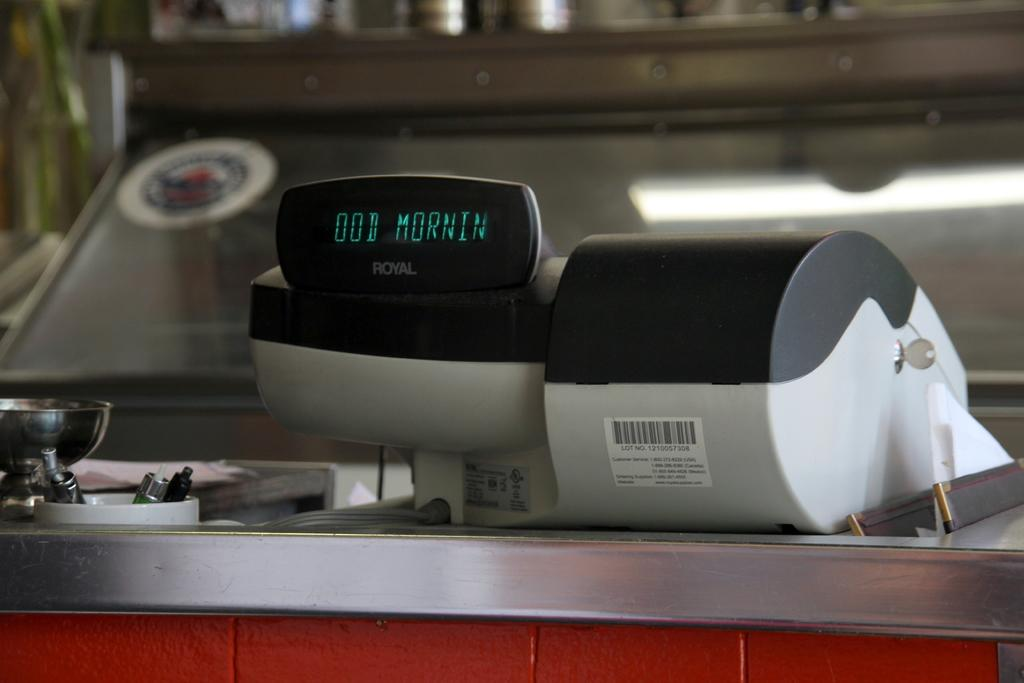Provide a one-sentence caption for the provided image. a royal device has the letters ood morning on the screen. 